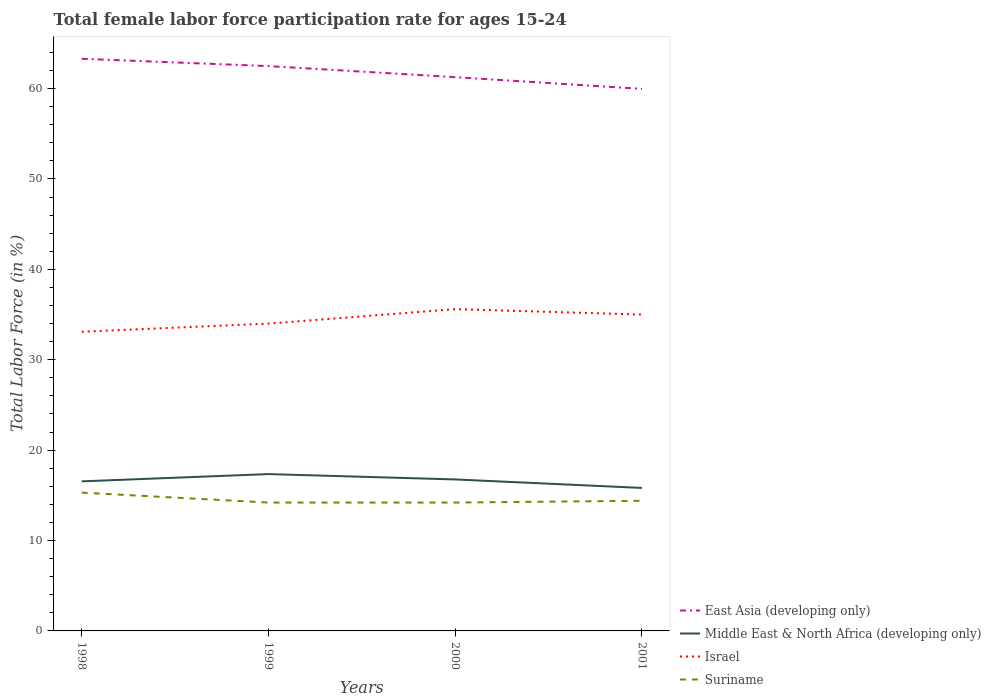Does the line corresponding to East Asia (developing only) intersect with the line corresponding to Suriname?
Your answer should be very brief. No. Across all years, what is the maximum female labor force participation rate in Israel?
Your answer should be compact. 33.1. In which year was the female labor force participation rate in Suriname maximum?
Your response must be concise. 1999. What is the total female labor force participation rate in Middle East & North Africa (developing only) in the graph?
Your answer should be compact. 0.73. What is the difference between the highest and the second highest female labor force participation rate in Middle East & North Africa (developing only)?
Make the answer very short. 1.53. Is the female labor force participation rate in Suriname strictly greater than the female labor force participation rate in East Asia (developing only) over the years?
Keep it short and to the point. Yes. What is the difference between two consecutive major ticks on the Y-axis?
Offer a very short reply. 10. Does the graph contain grids?
Ensure brevity in your answer.  No. Where does the legend appear in the graph?
Your answer should be very brief. Bottom right. How are the legend labels stacked?
Offer a terse response. Vertical. What is the title of the graph?
Your answer should be compact. Total female labor force participation rate for ages 15-24. What is the label or title of the X-axis?
Offer a terse response. Years. What is the Total Labor Force (in %) of East Asia (developing only) in 1998?
Give a very brief answer. 63.3. What is the Total Labor Force (in %) of Middle East & North Africa (developing only) in 1998?
Your answer should be very brief. 16.55. What is the Total Labor Force (in %) in Israel in 1998?
Ensure brevity in your answer.  33.1. What is the Total Labor Force (in %) in Suriname in 1998?
Keep it short and to the point. 15.3. What is the Total Labor Force (in %) in East Asia (developing only) in 1999?
Offer a very short reply. 62.49. What is the Total Labor Force (in %) in Middle East & North Africa (developing only) in 1999?
Provide a short and direct response. 17.35. What is the Total Labor Force (in %) of Suriname in 1999?
Give a very brief answer. 14.2. What is the Total Labor Force (in %) of East Asia (developing only) in 2000?
Ensure brevity in your answer.  61.26. What is the Total Labor Force (in %) in Middle East & North Africa (developing only) in 2000?
Ensure brevity in your answer.  16.76. What is the Total Labor Force (in %) of Israel in 2000?
Make the answer very short. 35.6. What is the Total Labor Force (in %) of Suriname in 2000?
Ensure brevity in your answer.  14.2. What is the Total Labor Force (in %) in East Asia (developing only) in 2001?
Provide a short and direct response. 59.97. What is the Total Labor Force (in %) of Middle East & North Africa (developing only) in 2001?
Make the answer very short. 15.82. What is the Total Labor Force (in %) in Suriname in 2001?
Your response must be concise. 14.4. Across all years, what is the maximum Total Labor Force (in %) in East Asia (developing only)?
Make the answer very short. 63.3. Across all years, what is the maximum Total Labor Force (in %) in Middle East & North Africa (developing only)?
Make the answer very short. 17.35. Across all years, what is the maximum Total Labor Force (in %) of Israel?
Offer a very short reply. 35.6. Across all years, what is the maximum Total Labor Force (in %) in Suriname?
Provide a short and direct response. 15.3. Across all years, what is the minimum Total Labor Force (in %) of East Asia (developing only)?
Offer a very short reply. 59.97. Across all years, what is the minimum Total Labor Force (in %) in Middle East & North Africa (developing only)?
Keep it short and to the point. 15.82. Across all years, what is the minimum Total Labor Force (in %) in Israel?
Make the answer very short. 33.1. Across all years, what is the minimum Total Labor Force (in %) in Suriname?
Your answer should be very brief. 14.2. What is the total Total Labor Force (in %) in East Asia (developing only) in the graph?
Your answer should be very brief. 247.02. What is the total Total Labor Force (in %) in Middle East & North Africa (developing only) in the graph?
Your response must be concise. 66.48. What is the total Total Labor Force (in %) in Israel in the graph?
Keep it short and to the point. 137.7. What is the total Total Labor Force (in %) in Suriname in the graph?
Your answer should be compact. 58.1. What is the difference between the Total Labor Force (in %) in East Asia (developing only) in 1998 and that in 1999?
Ensure brevity in your answer.  0.81. What is the difference between the Total Labor Force (in %) of Middle East & North Africa (developing only) in 1998 and that in 1999?
Your answer should be compact. -0.8. What is the difference between the Total Labor Force (in %) of Israel in 1998 and that in 1999?
Keep it short and to the point. -0.9. What is the difference between the Total Labor Force (in %) of Suriname in 1998 and that in 1999?
Offer a terse response. 1.1. What is the difference between the Total Labor Force (in %) of East Asia (developing only) in 1998 and that in 2000?
Ensure brevity in your answer.  2.04. What is the difference between the Total Labor Force (in %) of Middle East & North Africa (developing only) in 1998 and that in 2000?
Provide a succinct answer. -0.21. What is the difference between the Total Labor Force (in %) in East Asia (developing only) in 1998 and that in 2001?
Offer a terse response. 3.33. What is the difference between the Total Labor Force (in %) of Middle East & North Africa (developing only) in 1998 and that in 2001?
Provide a short and direct response. 0.73. What is the difference between the Total Labor Force (in %) in East Asia (developing only) in 1999 and that in 2000?
Keep it short and to the point. 1.23. What is the difference between the Total Labor Force (in %) in Middle East & North Africa (developing only) in 1999 and that in 2000?
Offer a terse response. 0.59. What is the difference between the Total Labor Force (in %) in Israel in 1999 and that in 2000?
Your answer should be very brief. -1.6. What is the difference between the Total Labor Force (in %) of Suriname in 1999 and that in 2000?
Keep it short and to the point. 0. What is the difference between the Total Labor Force (in %) of East Asia (developing only) in 1999 and that in 2001?
Your response must be concise. 2.52. What is the difference between the Total Labor Force (in %) of Middle East & North Africa (developing only) in 1999 and that in 2001?
Provide a short and direct response. 1.53. What is the difference between the Total Labor Force (in %) in Israel in 1999 and that in 2001?
Make the answer very short. -1. What is the difference between the Total Labor Force (in %) in Suriname in 1999 and that in 2001?
Offer a terse response. -0.2. What is the difference between the Total Labor Force (in %) in East Asia (developing only) in 2000 and that in 2001?
Your response must be concise. 1.3. What is the difference between the Total Labor Force (in %) of Middle East & North Africa (developing only) in 2000 and that in 2001?
Provide a succinct answer. 0.94. What is the difference between the Total Labor Force (in %) of Suriname in 2000 and that in 2001?
Keep it short and to the point. -0.2. What is the difference between the Total Labor Force (in %) in East Asia (developing only) in 1998 and the Total Labor Force (in %) in Middle East & North Africa (developing only) in 1999?
Your answer should be very brief. 45.95. What is the difference between the Total Labor Force (in %) of East Asia (developing only) in 1998 and the Total Labor Force (in %) of Israel in 1999?
Ensure brevity in your answer.  29.3. What is the difference between the Total Labor Force (in %) of East Asia (developing only) in 1998 and the Total Labor Force (in %) of Suriname in 1999?
Keep it short and to the point. 49.1. What is the difference between the Total Labor Force (in %) in Middle East & North Africa (developing only) in 1998 and the Total Labor Force (in %) in Israel in 1999?
Your answer should be very brief. -17.45. What is the difference between the Total Labor Force (in %) in Middle East & North Africa (developing only) in 1998 and the Total Labor Force (in %) in Suriname in 1999?
Offer a terse response. 2.35. What is the difference between the Total Labor Force (in %) of Israel in 1998 and the Total Labor Force (in %) of Suriname in 1999?
Give a very brief answer. 18.9. What is the difference between the Total Labor Force (in %) in East Asia (developing only) in 1998 and the Total Labor Force (in %) in Middle East & North Africa (developing only) in 2000?
Keep it short and to the point. 46.54. What is the difference between the Total Labor Force (in %) of East Asia (developing only) in 1998 and the Total Labor Force (in %) of Israel in 2000?
Provide a short and direct response. 27.7. What is the difference between the Total Labor Force (in %) of East Asia (developing only) in 1998 and the Total Labor Force (in %) of Suriname in 2000?
Ensure brevity in your answer.  49.1. What is the difference between the Total Labor Force (in %) of Middle East & North Africa (developing only) in 1998 and the Total Labor Force (in %) of Israel in 2000?
Your answer should be compact. -19.05. What is the difference between the Total Labor Force (in %) in Middle East & North Africa (developing only) in 1998 and the Total Labor Force (in %) in Suriname in 2000?
Give a very brief answer. 2.35. What is the difference between the Total Labor Force (in %) of East Asia (developing only) in 1998 and the Total Labor Force (in %) of Middle East & North Africa (developing only) in 2001?
Offer a very short reply. 47.48. What is the difference between the Total Labor Force (in %) in East Asia (developing only) in 1998 and the Total Labor Force (in %) in Israel in 2001?
Your answer should be very brief. 28.3. What is the difference between the Total Labor Force (in %) in East Asia (developing only) in 1998 and the Total Labor Force (in %) in Suriname in 2001?
Offer a very short reply. 48.9. What is the difference between the Total Labor Force (in %) in Middle East & North Africa (developing only) in 1998 and the Total Labor Force (in %) in Israel in 2001?
Your answer should be compact. -18.45. What is the difference between the Total Labor Force (in %) of Middle East & North Africa (developing only) in 1998 and the Total Labor Force (in %) of Suriname in 2001?
Give a very brief answer. 2.15. What is the difference between the Total Labor Force (in %) of Israel in 1998 and the Total Labor Force (in %) of Suriname in 2001?
Your answer should be very brief. 18.7. What is the difference between the Total Labor Force (in %) in East Asia (developing only) in 1999 and the Total Labor Force (in %) in Middle East & North Africa (developing only) in 2000?
Ensure brevity in your answer.  45.73. What is the difference between the Total Labor Force (in %) of East Asia (developing only) in 1999 and the Total Labor Force (in %) of Israel in 2000?
Offer a very short reply. 26.89. What is the difference between the Total Labor Force (in %) in East Asia (developing only) in 1999 and the Total Labor Force (in %) in Suriname in 2000?
Your response must be concise. 48.29. What is the difference between the Total Labor Force (in %) of Middle East & North Africa (developing only) in 1999 and the Total Labor Force (in %) of Israel in 2000?
Ensure brevity in your answer.  -18.25. What is the difference between the Total Labor Force (in %) of Middle East & North Africa (developing only) in 1999 and the Total Labor Force (in %) of Suriname in 2000?
Ensure brevity in your answer.  3.15. What is the difference between the Total Labor Force (in %) of Israel in 1999 and the Total Labor Force (in %) of Suriname in 2000?
Your response must be concise. 19.8. What is the difference between the Total Labor Force (in %) of East Asia (developing only) in 1999 and the Total Labor Force (in %) of Middle East & North Africa (developing only) in 2001?
Make the answer very short. 46.67. What is the difference between the Total Labor Force (in %) of East Asia (developing only) in 1999 and the Total Labor Force (in %) of Israel in 2001?
Offer a very short reply. 27.49. What is the difference between the Total Labor Force (in %) of East Asia (developing only) in 1999 and the Total Labor Force (in %) of Suriname in 2001?
Your answer should be very brief. 48.09. What is the difference between the Total Labor Force (in %) in Middle East & North Africa (developing only) in 1999 and the Total Labor Force (in %) in Israel in 2001?
Your answer should be compact. -17.65. What is the difference between the Total Labor Force (in %) in Middle East & North Africa (developing only) in 1999 and the Total Labor Force (in %) in Suriname in 2001?
Keep it short and to the point. 2.95. What is the difference between the Total Labor Force (in %) in Israel in 1999 and the Total Labor Force (in %) in Suriname in 2001?
Provide a succinct answer. 19.6. What is the difference between the Total Labor Force (in %) of East Asia (developing only) in 2000 and the Total Labor Force (in %) of Middle East & North Africa (developing only) in 2001?
Give a very brief answer. 45.44. What is the difference between the Total Labor Force (in %) in East Asia (developing only) in 2000 and the Total Labor Force (in %) in Israel in 2001?
Give a very brief answer. 26.26. What is the difference between the Total Labor Force (in %) in East Asia (developing only) in 2000 and the Total Labor Force (in %) in Suriname in 2001?
Your response must be concise. 46.86. What is the difference between the Total Labor Force (in %) in Middle East & North Africa (developing only) in 2000 and the Total Labor Force (in %) in Israel in 2001?
Your answer should be compact. -18.24. What is the difference between the Total Labor Force (in %) in Middle East & North Africa (developing only) in 2000 and the Total Labor Force (in %) in Suriname in 2001?
Your response must be concise. 2.36. What is the difference between the Total Labor Force (in %) of Israel in 2000 and the Total Labor Force (in %) of Suriname in 2001?
Your answer should be compact. 21.2. What is the average Total Labor Force (in %) in East Asia (developing only) per year?
Offer a very short reply. 61.75. What is the average Total Labor Force (in %) of Middle East & North Africa (developing only) per year?
Make the answer very short. 16.62. What is the average Total Labor Force (in %) in Israel per year?
Provide a short and direct response. 34.42. What is the average Total Labor Force (in %) in Suriname per year?
Make the answer very short. 14.53. In the year 1998, what is the difference between the Total Labor Force (in %) in East Asia (developing only) and Total Labor Force (in %) in Middle East & North Africa (developing only)?
Offer a terse response. 46.75. In the year 1998, what is the difference between the Total Labor Force (in %) of East Asia (developing only) and Total Labor Force (in %) of Israel?
Your answer should be very brief. 30.2. In the year 1998, what is the difference between the Total Labor Force (in %) of East Asia (developing only) and Total Labor Force (in %) of Suriname?
Provide a succinct answer. 48. In the year 1998, what is the difference between the Total Labor Force (in %) of Middle East & North Africa (developing only) and Total Labor Force (in %) of Israel?
Make the answer very short. -16.55. In the year 1998, what is the difference between the Total Labor Force (in %) in Middle East & North Africa (developing only) and Total Labor Force (in %) in Suriname?
Offer a very short reply. 1.25. In the year 1998, what is the difference between the Total Labor Force (in %) of Israel and Total Labor Force (in %) of Suriname?
Your response must be concise. 17.8. In the year 1999, what is the difference between the Total Labor Force (in %) in East Asia (developing only) and Total Labor Force (in %) in Middle East & North Africa (developing only)?
Your response must be concise. 45.14. In the year 1999, what is the difference between the Total Labor Force (in %) in East Asia (developing only) and Total Labor Force (in %) in Israel?
Offer a terse response. 28.49. In the year 1999, what is the difference between the Total Labor Force (in %) of East Asia (developing only) and Total Labor Force (in %) of Suriname?
Offer a very short reply. 48.29. In the year 1999, what is the difference between the Total Labor Force (in %) in Middle East & North Africa (developing only) and Total Labor Force (in %) in Israel?
Provide a short and direct response. -16.65. In the year 1999, what is the difference between the Total Labor Force (in %) of Middle East & North Africa (developing only) and Total Labor Force (in %) of Suriname?
Your response must be concise. 3.15. In the year 1999, what is the difference between the Total Labor Force (in %) in Israel and Total Labor Force (in %) in Suriname?
Your answer should be very brief. 19.8. In the year 2000, what is the difference between the Total Labor Force (in %) in East Asia (developing only) and Total Labor Force (in %) in Middle East & North Africa (developing only)?
Provide a succinct answer. 44.5. In the year 2000, what is the difference between the Total Labor Force (in %) of East Asia (developing only) and Total Labor Force (in %) of Israel?
Ensure brevity in your answer.  25.66. In the year 2000, what is the difference between the Total Labor Force (in %) in East Asia (developing only) and Total Labor Force (in %) in Suriname?
Offer a very short reply. 47.06. In the year 2000, what is the difference between the Total Labor Force (in %) of Middle East & North Africa (developing only) and Total Labor Force (in %) of Israel?
Offer a very short reply. -18.84. In the year 2000, what is the difference between the Total Labor Force (in %) in Middle East & North Africa (developing only) and Total Labor Force (in %) in Suriname?
Make the answer very short. 2.56. In the year 2000, what is the difference between the Total Labor Force (in %) of Israel and Total Labor Force (in %) of Suriname?
Offer a terse response. 21.4. In the year 2001, what is the difference between the Total Labor Force (in %) in East Asia (developing only) and Total Labor Force (in %) in Middle East & North Africa (developing only)?
Your answer should be compact. 44.15. In the year 2001, what is the difference between the Total Labor Force (in %) of East Asia (developing only) and Total Labor Force (in %) of Israel?
Your answer should be very brief. 24.97. In the year 2001, what is the difference between the Total Labor Force (in %) in East Asia (developing only) and Total Labor Force (in %) in Suriname?
Ensure brevity in your answer.  45.57. In the year 2001, what is the difference between the Total Labor Force (in %) of Middle East & North Africa (developing only) and Total Labor Force (in %) of Israel?
Provide a succinct answer. -19.18. In the year 2001, what is the difference between the Total Labor Force (in %) of Middle East & North Africa (developing only) and Total Labor Force (in %) of Suriname?
Make the answer very short. 1.42. In the year 2001, what is the difference between the Total Labor Force (in %) of Israel and Total Labor Force (in %) of Suriname?
Provide a succinct answer. 20.6. What is the ratio of the Total Labor Force (in %) of Middle East & North Africa (developing only) in 1998 to that in 1999?
Your answer should be very brief. 0.95. What is the ratio of the Total Labor Force (in %) of Israel in 1998 to that in 1999?
Your answer should be compact. 0.97. What is the ratio of the Total Labor Force (in %) of Suriname in 1998 to that in 1999?
Provide a succinct answer. 1.08. What is the ratio of the Total Labor Force (in %) in East Asia (developing only) in 1998 to that in 2000?
Provide a succinct answer. 1.03. What is the ratio of the Total Labor Force (in %) in Middle East & North Africa (developing only) in 1998 to that in 2000?
Make the answer very short. 0.99. What is the ratio of the Total Labor Force (in %) in Israel in 1998 to that in 2000?
Ensure brevity in your answer.  0.93. What is the ratio of the Total Labor Force (in %) of Suriname in 1998 to that in 2000?
Ensure brevity in your answer.  1.08. What is the ratio of the Total Labor Force (in %) in East Asia (developing only) in 1998 to that in 2001?
Provide a succinct answer. 1.06. What is the ratio of the Total Labor Force (in %) of Middle East & North Africa (developing only) in 1998 to that in 2001?
Your answer should be compact. 1.05. What is the ratio of the Total Labor Force (in %) in Israel in 1998 to that in 2001?
Your response must be concise. 0.95. What is the ratio of the Total Labor Force (in %) in Middle East & North Africa (developing only) in 1999 to that in 2000?
Keep it short and to the point. 1.04. What is the ratio of the Total Labor Force (in %) in Israel in 1999 to that in 2000?
Make the answer very short. 0.96. What is the ratio of the Total Labor Force (in %) of Suriname in 1999 to that in 2000?
Give a very brief answer. 1. What is the ratio of the Total Labor Force (in %) of East Asia (developing only) in 1999 to that in 2001?
Offer a very short reply. 1.04. What is the ratio of the Total Labor Force (in %) in Middle East & North Africa (developing only) in 1999 to that in 2001?
Keep it short and to the point. 1.1. What is the ratio of the Total Labor Force (in %) in Israel in 1999 to that in 2001?
Make the answer very short. 0.97. What is the ratio of the Total Labor Force (in %) in Suriname in 1999 to that in 2001?
Keep it short and to the point. 0.99. What is the ratio of the Total Labor Force (in %) of East Asia (developing only) in 2000 to that in 2001?
Provide a succinct answer. 1.02. What is the ratio of the Total Labor Force (in %) of Middle East & North Africa (developing only) in 2000 to that in 2001?
Keep it short and to the point. 1.06. What is the ratio of the Total Labor Force (in %) in Israel in 2000 to that in 2001?
Give a very brief answer. 1.02. What is the ratio of the Total Labor Force (in %) in Suriname in 2000 to that in 2001?
Offer a very short reply. 0.99. What is the difference between the highest and the second highest Total Labor Force (in %) of East Asia (developing only)?
Provide a succinct answer. 0.81. What is the difference between the highest and the second highest Total Labor Force (in %) of Middle East & North Africa (developing only)?
Ensure brevity in your answer.  0.59. What is the difference between the highest and the lowest Total Labor Force (in %) of East Asia (developing only)?
Keep it short and to the point. 3.33. What is the difference between the highest and the lowest Total Labor Force (in %) of Middle East & North Africa (developing only)?
Your response must be concise. 1.53. 